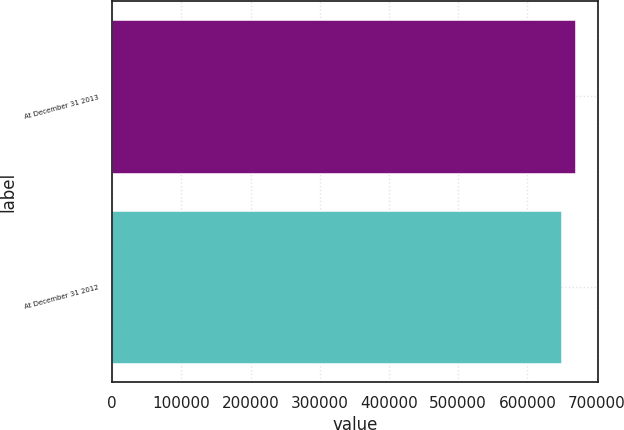Convert chart to OTSL. <chart><loc_0><loc_0><loc_500><loc_500><bar_chart><fcel>At December 31 2013<fcel>At December 31 2012<nl><fcel>668596<fcel>648049<nl></chart> 